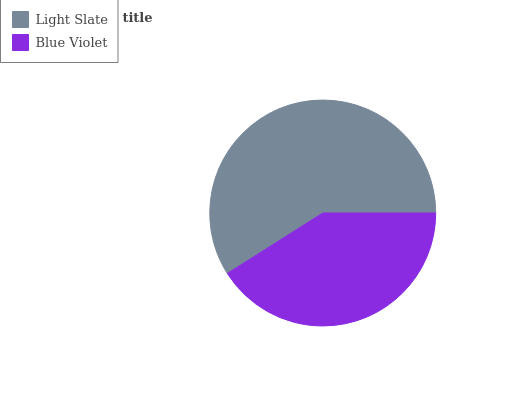Is Blue Violet the minimum?
Answer yes or no. Yes. Is Light Slate the maximum?
Answer yes or no. Yes. Is Blue Violet the maximum?
Answer yes or no. No. Is Light Slate greater than Blue Violet?
Answer yes or no. Yes. Is Blue Violet less than Light Slate?
Answer yes or no. Yes. Is Blue Violet greater than Light Slate?
Answer yes or no. No. Is Light Slate less than Blue Violet?
Answer yes or no. No. Is Light Slate the high median?
Answer yes or no. Yes. Is Blue Violet the low median?
Answer yes or no. Yes. Is Blue Violet the high median?
Answer yes or no. No. Is Light Slate the low median?
Answer yes or no. No. 